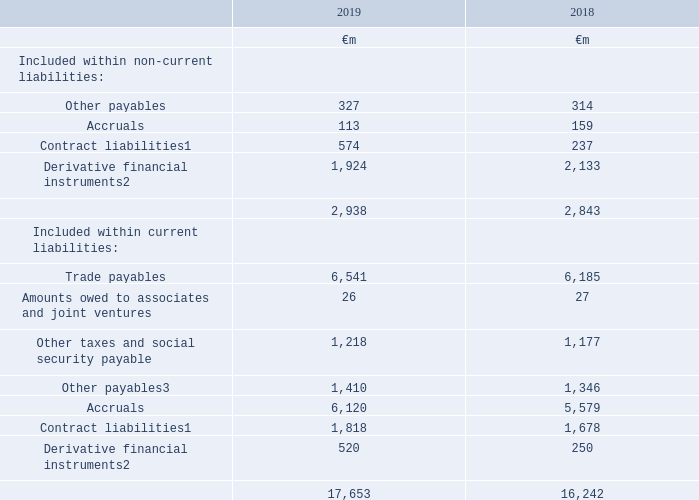15. Trade and other payables
Trade and other payables mainly consist of amounts owed to suppliers that have been invoiced or are accrued and contract liabilities relating to consideration received from customers in advance. They also include taxes and social security amounts due in relation to the Group’s role as an employer. Derivative financial instruments with a negative market value are reported within this note.
Accounting policies
Trade payables are not interest-bearing and are stated at their nominal value.
Notes: 1 Previously described as deferred income in the year ended 31 March 2018
2 Items are measured at fair value and the valuation basis is level 2 classification, which comprises items where fair value is determined from inputs other than quoted prices that are observable for the asset or liability, either directly or indirectly
3 Includes €823 million (2018: €nil) payable in relation to the irrevocable and non-discretionary share buyback programme announced in January 2019.
The carrying amounts of trade and other payables approximate their fair value.
Materially all of the €1,716 million recorded as current contract liabilities at 1 April 2018 was recognised as revenue during the year.
Other payables included within non-current liabilities include €288 million (2018: €271 million) in respect of the re-insurance of a third party annuity policy related to the Vodafone and CWW Sections of the Vodafone UK Group Pension Scheme.
The fair values of the derivative financial instruments are calculated by discounting the future cash flows to net present values using appropriate market interest rates and foreign currency rates prevailing at 31 March.
Which financial years' information is shown in the table? 2018, 2019. How much is the 2019 other payables included within non-current liabilities?
Answer scale should be: million. 327. How much is the 2018 other payables included within non-current liabilities?
Answer scale should be: million. 314. Between 2018 and 2019, which year had higher total trade and other payables included within current liabilities? 17,653>16,242
Answer: 2019. Between 2018 and 2019, which year had higher accruals included within non-current liabilities? 159>113
Answer: 2018. How much is the 2019 other payables included within current liabilities excluding the amount payable in relation to the share buyback?
Answer scale should be: million. 1,410-823
Answer: 587. 